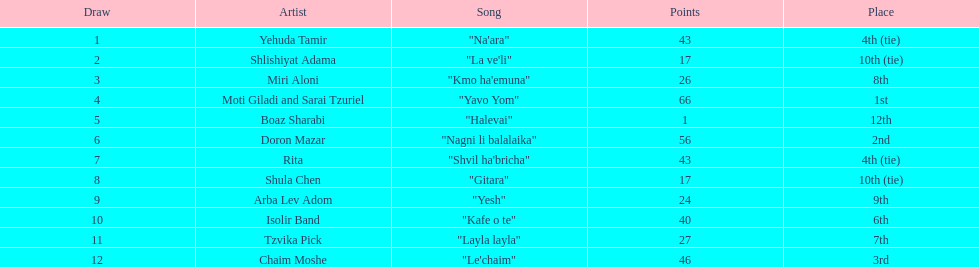Who were all the participants at the competition? Yehuda Tamir, Shlishiyat Adama, Miri Aloni, Moti Giladi and Sarai Tzuriel, Boaz Sharabi, Doron Mazar, Rita, Shula Chen, Arba Lev Adom, Isolir Band, Tzvika Pick, Chaim Moshe. What were their scores? 43, 17, 26, 66, 1, 56, 43, 17, 24, 40, 27, 46. Among these, which is the smallest number of points? 1. Which participants obtained this score? Boaz Sharabi. 